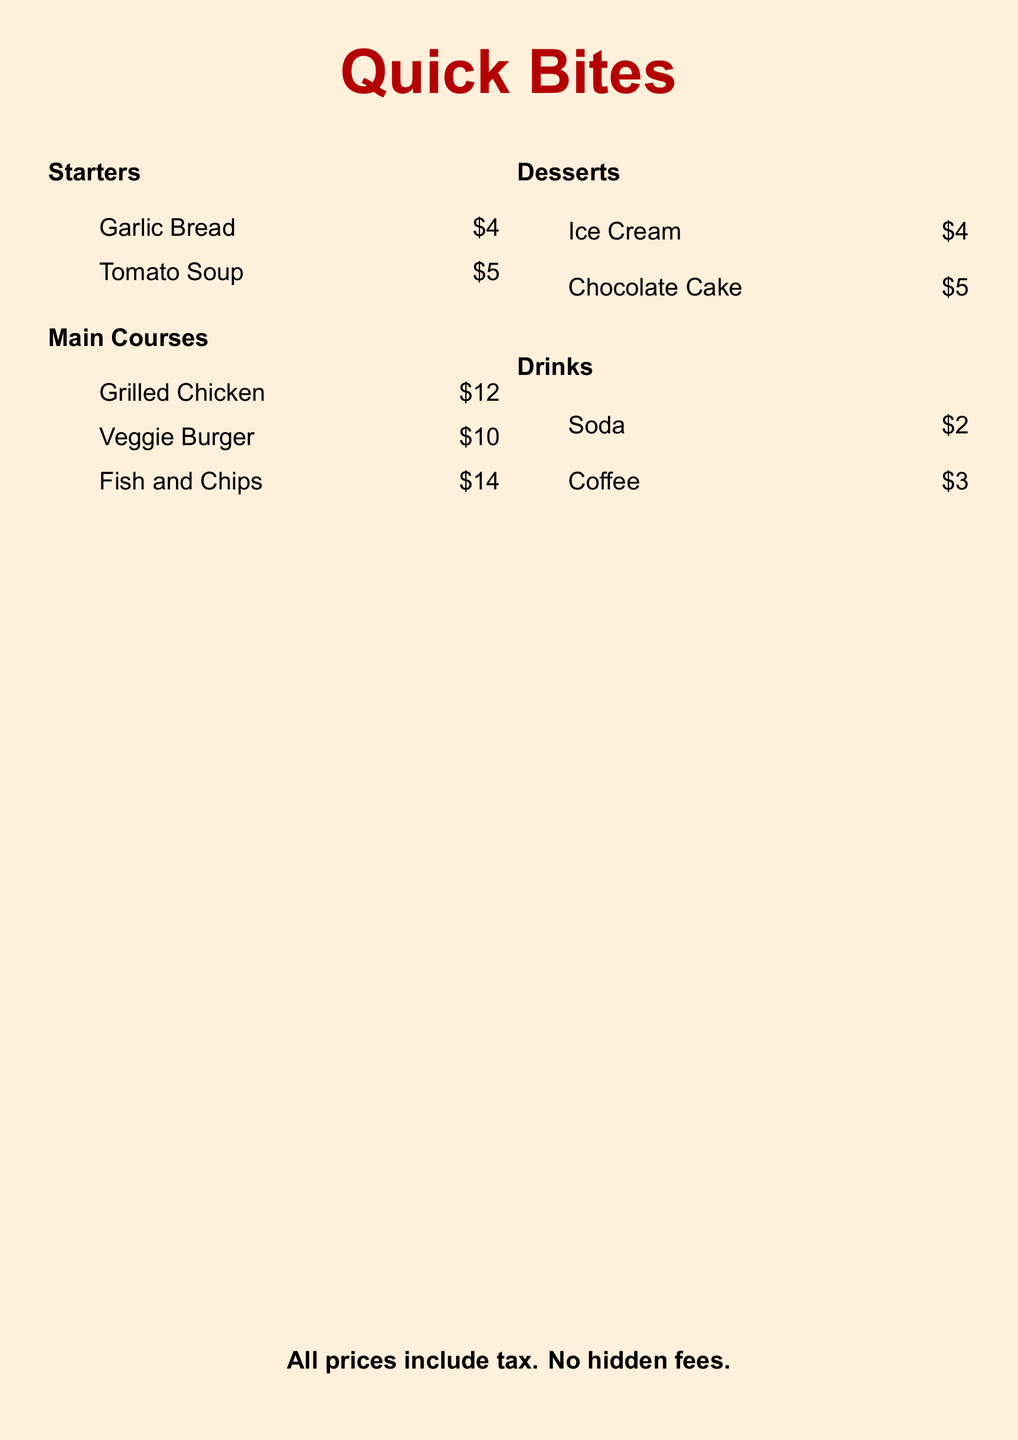What is the name of the restaurant? The restaurant name is indicated in the title of the menu, which is "Quick Bites."
Answer: Quick Bites How much does the Garlic Bread cost? The price of Garlic Bread is listed next to the item in the menu.
Answer: $4 What are the two dessert options available? The two dessert options are mentioned under the Desserts section, which lists Ice Cream and Chocolate Cake.
Answer: Ice Cream, Chocolate Cake What is the price of the Veggie Burger? The price of the Veggie Burger can be found next to the item in the menu.
Answer: $10 How many drink options are listed? The number of drink options is determined by counting the items under the Drinks section.
Answer: 2 Which main course is the most expensive? The most expensive main course can be found by comparing the prices listed under the Main Courses section.
Answer: Fish and Chips What is the total price of the Starters? The total price is calculated by adding the prices of Garlic Bread and Tomato Soup presented in the Starters section.
Answer: $9 Is tax included in the prices? The note at the bottom of the menu states that all prices include tax.
Answer: Yes What is the cheapest drink option? The price of the drinks is indicated, allowing us to identify the cheapest one under the Drinks section.
Answer: $2 